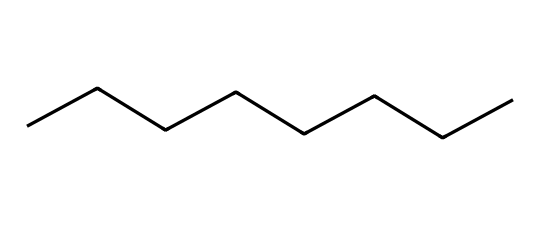How many carbon atoms are present in this structure? The provided SMILES, CCCCCCCC, indicates a linear chain of eight carbon atoms. Each 'C' represents a carbon atom, and there are eight of them in total.
Answer: eight What type of chemical bond is primarily present in this molecule? The SMILES representation indicates that the molecule consists of carbon atoms connected in a straight chain. This type of connection typically shows single bonds between carbon atoms, which is characteristic of alkanes.
Answer: single What is the chemical name of this compound? The SMILES shows a straight-chain alkane with eight carbon atoms, which is named octane in organic chemistry. The structure specifies that it is an unbranched alkane.
Answer: octane Is this compound flammable? Octane, as an alkane, is a hydrocarbon, and hydrocarbons are generally flammable liquids. The molecular structure and functional groups indicate that it can ignite and burn easily in the presence of an oxidant.
Answer: yes What is the significance of the number of hydrogen atoms in the context of flammability? A fully saturated alkane like octane (C8H18) has the maximum number of hydrogen atoms possible for its carbon count. This saturation contributes to its high energy content when burned, making it highly flammable. A higher hydrogen content generally means increased flammability when combusted.
Answer: higher energy content How many hydrogen atoms are attached to this molecule? For octane (C8H18), each carbon atom can form four bonds. Since there are eight carbons in a straight chain with single bonds, the two end carbons will each bond to three hydrogen atoms, while the six middle carbons bond to two hydrogens each, resulting in a total of eighteen hydrogen atoms.
Answer: eighteen 